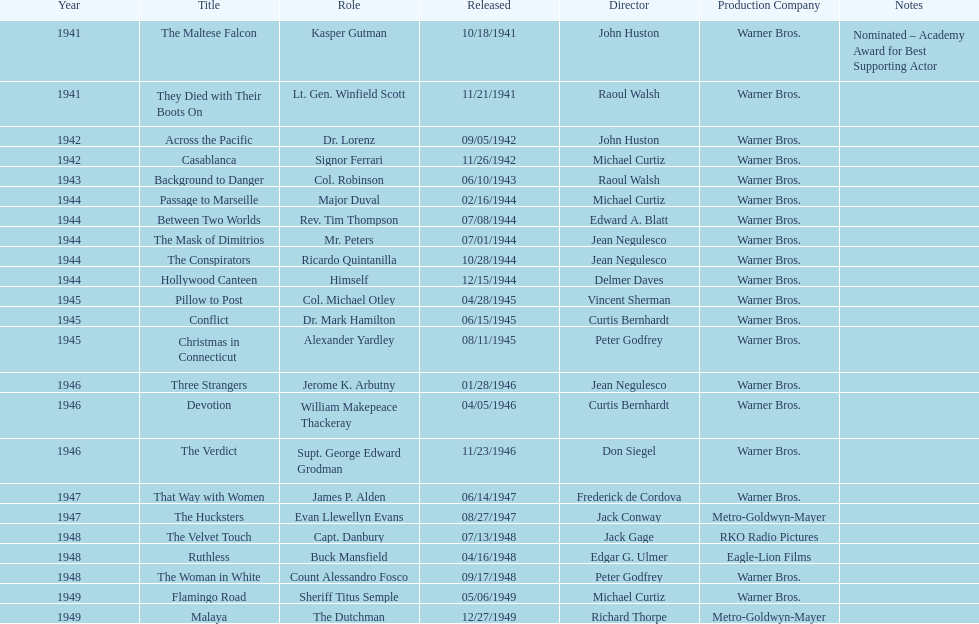How many films has he appeared in from 1941-1949? 23. 